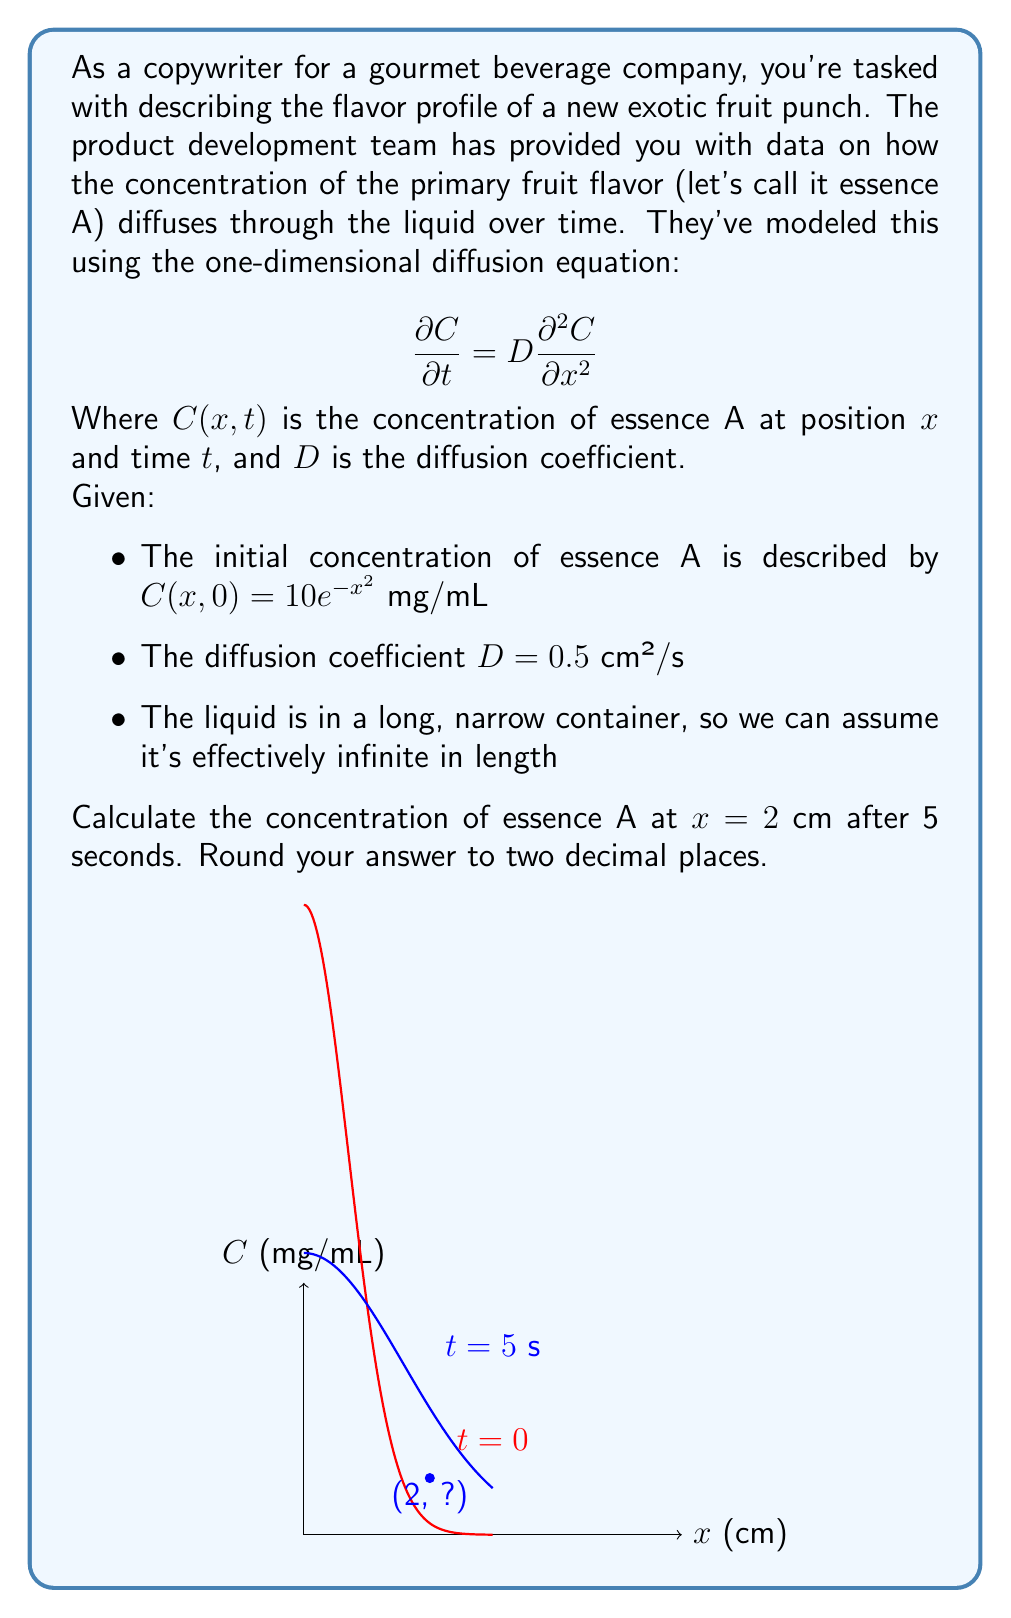Teach me how to tackle this problem. Let's approach this step-by-step:

1) The general solution to the diffusion equation in one dimension with an initial Gaussian distribution is:

   $$C(x,t) = \frac{M}{\sqrt{4\pi Dt}} e^{-\frac{x^2}{4Dt}}$$

   Where $M$ is a constant related to the total amount of substance.

2) We need to match this to our initial condition:

   $$C(x,0) = 10e^{-x^2} = \frac{M}{\sqrt{4\pi D \cdot 0}} e^{-\frac{x^2}{4D \cdot 0}}$$

3) This implies $M = 10\sqrt{\pi}$

4) Substituting this back into our general solution:

   $$C(x,t) = \frac{10\sqrt{\pi}}{\sqrt{4\pi Dt}} e^{-\frac{x^2}{4Dt}}$$

5) Simplifying:

   $$C(x,t) = \frac{10}{\sqrt{4Dt}} e^{-\frac{x^2}{4Dt}}$$

6) Now, let's plug in our values:
   $x = 2$ cm
   $t = 5$ s
   $D = 0.5$ cm²/s

   $$C(2,5) = \frac{10}{\sqrt{4 \cdot 0.5 \cdot 5}} e^{-\frac{2^2}{4 \cdot 0.5 \cdot 5}}$$

7) Simplifying:

   $$C(2,5) = \frac{10}{\sqrt{10}} e^{-\frac{4}{10}} = \frac{10}{\sqrt{10}} e^{-0.4}$$

8) Calculating:

   $$C(2,5) \approx 3.16 \cdot 0.67 \approx 2.12$$ mg/mL
Answer: 2.12 mg/mL 